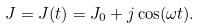Convert formula to latex. <formula><loc_0><loc_0><loc_500><loc_500>J = J ( t ) = J _ { 0 } + j \cos ( \omega t ) .</formula> 